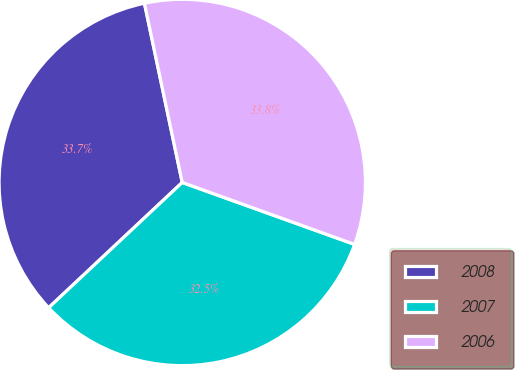Convert chart to OTSL. <chart><loc_0><loc_0><loc_500><loc_500><pie_chart><fcel>2008<fcel>2007<fcel>2006<nl><fcel>33.68%<fcel>32.52%<fcel>33.8%<nl></chart> 